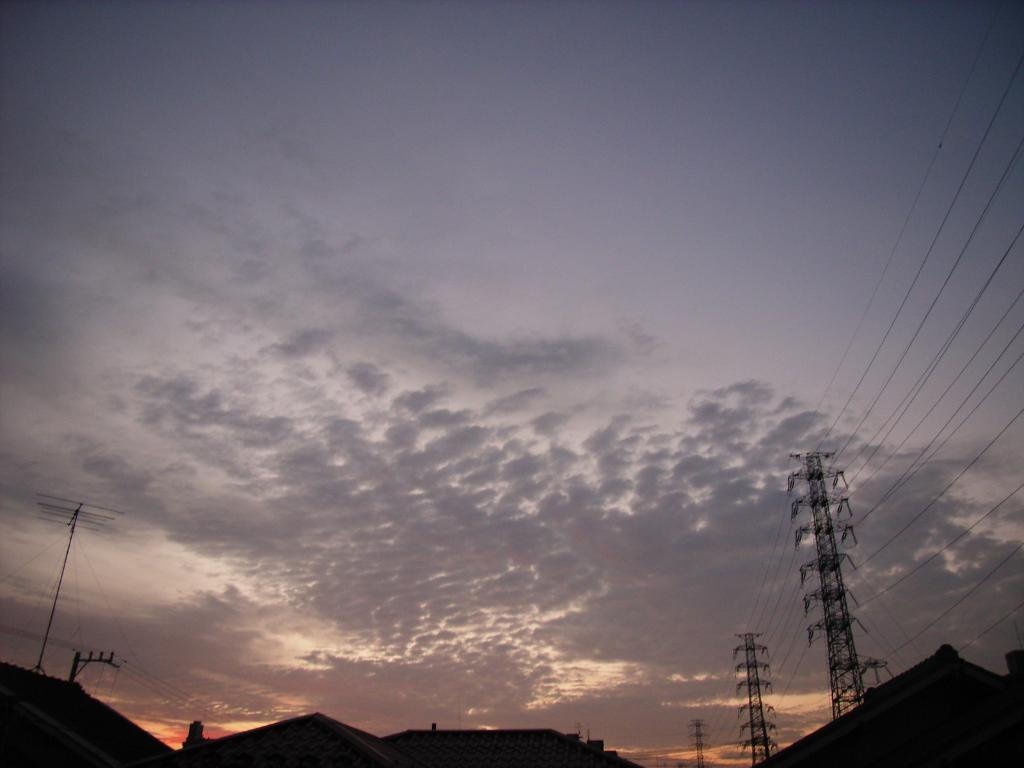What type of structures can be seen in the image? There are houses in the image. What other objects are present in the image? Current poles and high tension poles are in the image, along with wires. What can be seen in the sky in the image? Clouds are visible in the sky. How many bubbles can be seen floating around the houses in the image? There are no bubbles present in the image; it features houses, poles, and wires. What type of men can be seen interacting with the high tension poles in the image? There are no men present in the image; it only shows houses, poles, and wires. 